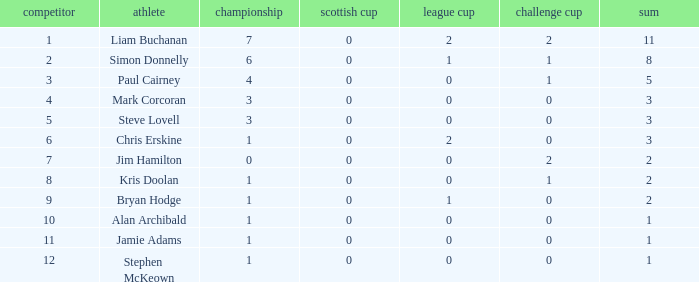What was the least number of points scored in the league cup? 0.0. 